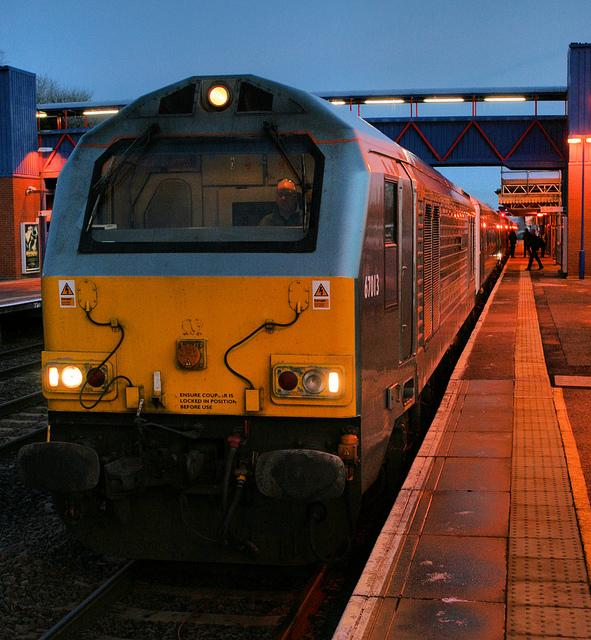What is the man inside the front of the training doing? Please explain your reasoning. driving. The man is steering the train. 